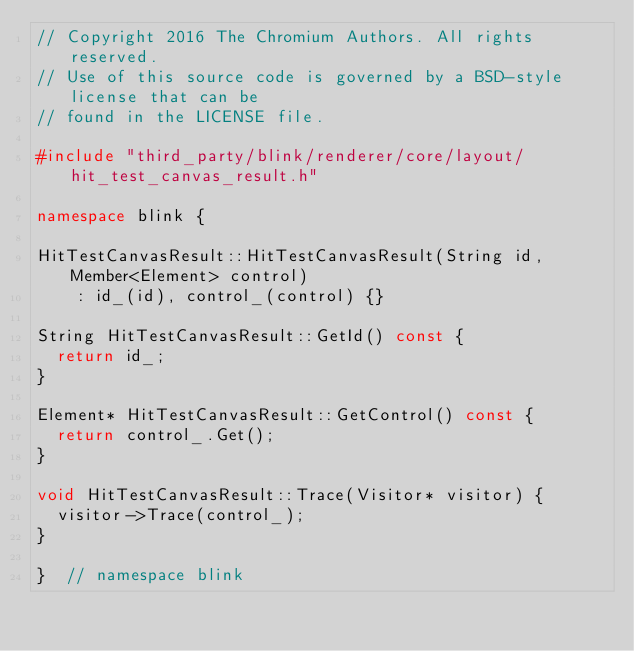Convert code to text. <code><loc_0><loc_0><loc_500><loc_500><_C++_>// Copyright 2016 The Chromium Authors. All rights reserved.
// Use of this source code is governed by a BSD-style license that can be
// found in the LICENSE file.

#include "third_party/blink/renderer/core/layout/hit_test_canvas_result.h"

namespace blink {

HitTestCanvasResult::HitTestCanvasResult(String id, Member<Element> control)
    : id_(id), control_(control) {}

String HitTestCanvasResult::GetId() const {
  return id_;
}

Element* HitTestCanvasResult::GetControl() const {
  return control_.Get();
}

void HitTestCanvasResult::Trace(Visitor* visitor) {
  visitor->Trace(control_);
}

}  // namespace blink
</code> 